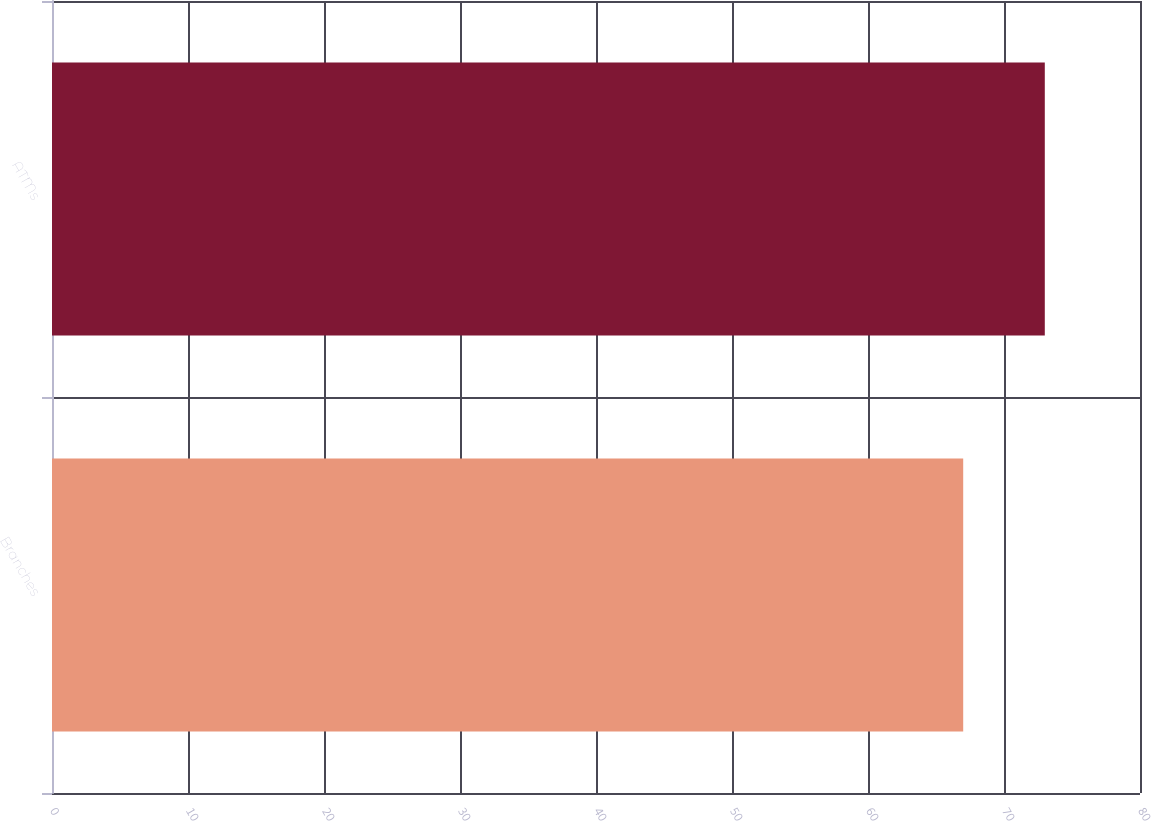<chart> <loc_0><loc_0><loc_500><loc_500><bar_chart><fcel>Branches<fcel>ATMs<nl><fcel>67<fcel>73<nl></chart> 